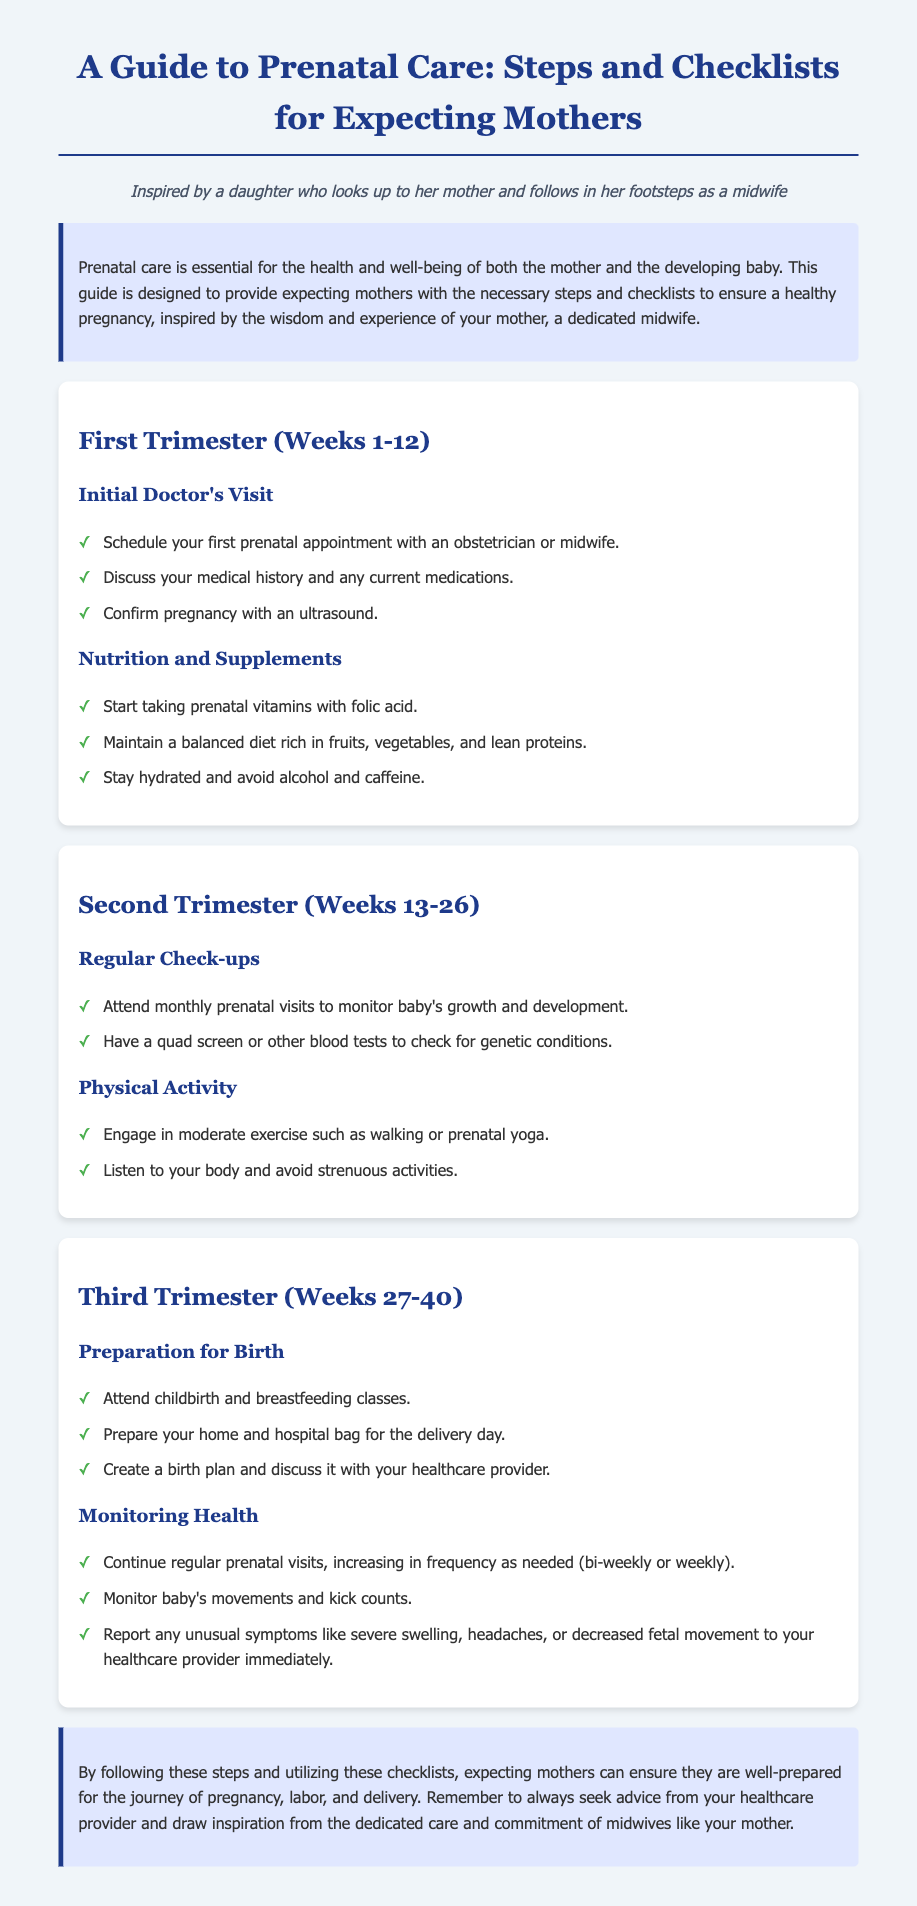What is the title of the guide? The title of the guide is prominently displayed at the top of the document and provides an overview of its contents.
Answer: A Guide to Prenatal Care: Steps and Checklists for Expecting Mothers How long is the first trimester? The document specifies the duration of each trimester, including the first one.
Answer: Weeks 1-12 What is one recommendation for nutrition in the first trimester? The document lists specific nutrition guidelines for expecting mothers in the first trimester.
Answer: Start taking prenatal vitamins with folic acid What type of exercise is recommended in the second trimester? The document mentions the kinds of physical activities that are appropriate during the second trimester.
Answer: Moderate exercise such as walking or prenatal yoga How often should prenatal visits occur in the third trimester? The frequency of prenatal visits during the third trimester is stated in the corresponding section of the document.
Answer: Bi-weekly or weekly What class should mothers attend in preparation for birth? One of the recommendations in the third trimester is for mothers to take certain classes.
Answer: Childbirth and breastfeeding classes Which health aspect needs to be monitored in the third trimester? The document emphasizes the importance of monitoring certain health indicators in the third trimester.
Answer: Baby's movements and kick counts What is the main purpose of this guide? The introduction outlines the overall intent of the guide and who it is designed for.
Answer: To provide expecting mothers with necessary steps and checklists for a healthy pregnancy 